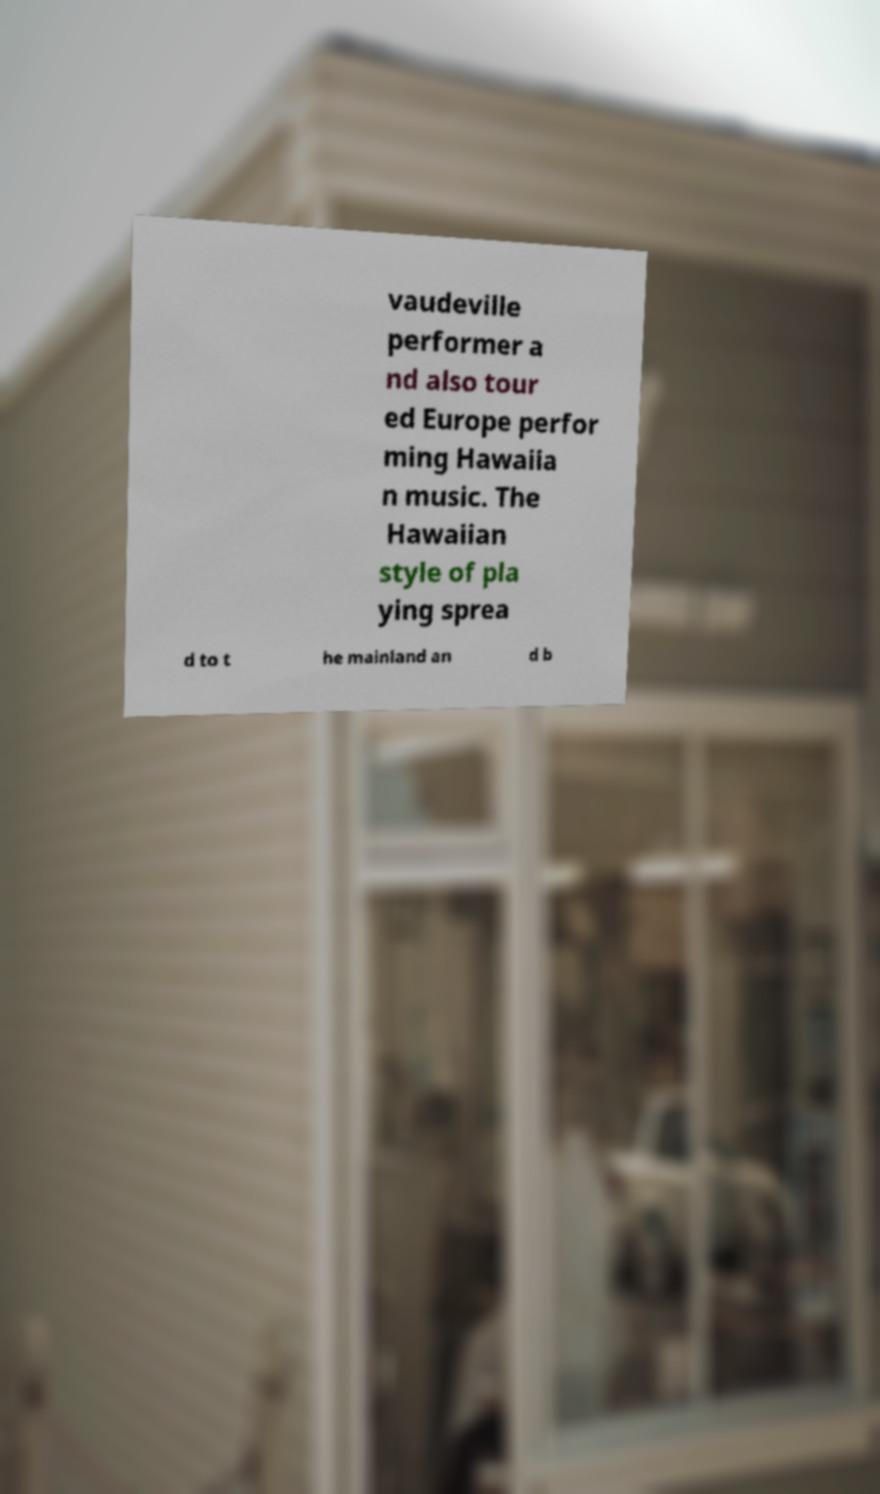Could you extract and type out the text from this image? vaudeville performer a nd also tour ed Europe perfor ming Hawaiia n music. The Hawaiian style of pla ying sprea d to t he mainland an d b 